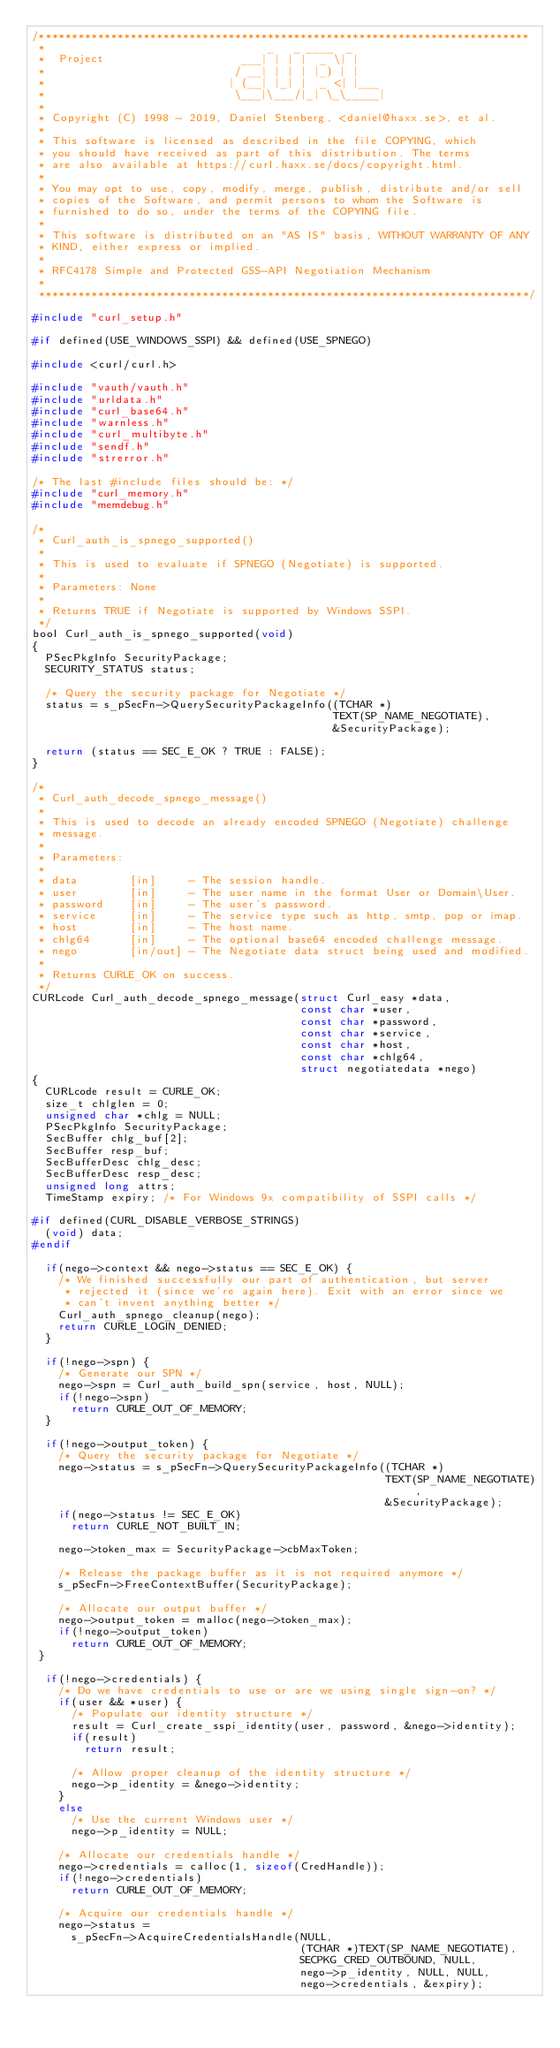<code> <loc_0><loc_0><loc_500><loc_500><_C_>/***************************************************************************
 *                                  _   _ ____  _
 *  Project                     ___| | | |  _ \| |
 *                             / __| | | | |_) | |
 *                            | (__| |_| |  _ <| |___
 *                             \___|\___/|_| \_\_____|
 *
 * Copyright (C) 1998 - 2019, Daniel Stenberg, <daniel@haxx.se>, et al.
 *
 * This software is licensed as described in the file COPYING, which
 * you should have received as part of this distribution. The terms
 * are also available at https://curl.haxx.se/docs/copyright.html.
 *
 * You may opt to use, copy, modify, merge, publish, distribute and/or sell
 * copies of the Software, and permit persons to whom the Software is
 * furnished to do so, under the terms of the COPYING file.
 *
 * This software is distributed on an "AS IS" basis, WITHOUT WARRANTY OF ANY
 * KIND, either express or implied.
 *
 * RFC4178 Simple and Protected GSS-API Negotiation Mechanism
 *
 ***************************************************************************/

#include "curl_setup.h"

#if defined(USE_WINDOWS_SSPI) && defined(USE_SPNEGO)

#include <curl/curl.h>

#include "vauth/vauth.h"
#include "urldata.h"
#include "curl_base64.h"
#include "warnless.h"
#include "curl_multibyte.h"
#include "sendf.h"
#include "strerror.h"

/* The last #include files should be: */
#include "curl_memory.h"
#include "memdebug.h"

/*
 * Curl_auth_is_spnego_supported()
 *
 * This is used to evaluate if SPNEGO (Negotiate) is supported.
 *
 * Parameters: None
 *
 * Returns TRUE if Negotiate is supported by Windows SSPI.
 */
bool Curl_auth_is_spnego_supported(void)
{
  PSecPkgInfo SecurityPackage;
  SECURITY_STATUS status;

  /* Query the security package for Negotiate */
  status = s_pSecFn->QuerySecurityPackageInfo((TCHAR *)
                                              TEXT(SP_NAME_NEGOTIATE),
                                              &SecurityPackage);

  return (status == SEC_E_OK ? TRUE : FALSE);
}

/*
 * Curl_auth_decode_spnego_message()
 *
 * This is used to decode an already encoded SPNEGO (Negotiate) challenge
 * message.
 *
 * Parameters:
 *
 * data        [in]     - The session handle.
 * user        [in]     - The user name in the format User or Domain\User.
 * password    [in]     - The user's password.
 * service     [in]     - The service type such as http, smtp, pop or imap.
 * host        [in]     - The host name.
 * chlg64      [in]     - The optional base64 encoded challenge message.
 * nego        [in/out] - The Negotiate data struct being used and modified.
 *
 * Returns CURLE_OK on success.
 */
CURLcode Curl_auth_decode_spnego_message(struct Curl_easy *data,
                                         const char *user,
                                         const char *password,
                                         const char *service,
                                         const char *host,
                                         const char *chlg64,
                                         struct negotiatedata *nego)
{
  CURLcode result = CURLE_OK;
  size_t chlglen = 0;
  unsigned char *chlg = NULL;
  PSecPkgInfo SecurityPackage;
  SecBuffer chlg_buf[2];
  SecBuffer resp_buf;
  SecBufferDesc chlg_desc;
  SecBufferDesc resp_desc;
  unsigned long attrs;
  TimeStamp expiry; /* For Windows 9x compatibility of SSPI calls */

#if defined(CURL_DISABLE_VERBOSE_STRINGS)
  (void) data;
#endif

  if(nego->context && nego->status == SEC_E_OK) {
    /* We finished successfully our part of authentication, but server
     * rejected it (since we're again here). Exit with an error since we
     * can't invent anything better */
    Curl_auth_spnego_cleanup(nego);
    return CURLE_LOGIN_DENIED;
  }

  if(!nego->spn) {
    /* Generate our SPN */
    nego->spn = Curl_auth_build_spn(service, host, NULL);
    if(!nego->spn)
      return CURLE_OUT_OF_MEMORY;
  }

  if(!nego->output_token) {
    /* Query the security package for Negotiate */
    nego->status = s_pSecFn->QuerySecurityPackageInfo((TCHAR *)
                                                      TEXT(SP_NAME_NEGOTIATE),
                                                      &SecurityPackage);
    if(nego->status != SEC_E_OK)
      return CURLE_NOT_BUILT_IN;

    nego->token_max = SecurityPackage->cbMaxToken;

    /* Release the package buffer as it is not required anymore */
    s_pSecFn->FreeContextBuffer(SecurityPackage);

    /* Allocate our output buffer */
    nego->output_token = malloc(nego->token_max);
    if(!nego->output_token)
      return CURLE_OUT_OF_MEMORY;
 }

  if(!nego->credentials) {
    /* Do we have credentials to use or are we using single sign-on? */
    if(user && *user) {
      /* Populate our identity structure */
      result = Curl_create_sspi_identity(user, password, &nego->identity);
      if(result)
        return result;

      /* Allow proper cleanup of the identity structure */
      nego->p_identity = &nego->identity;
    }
    else
      /* Use the current Windows user */
      nego->p_identity = NULL;

    /* Allocate our credentials handle */
    nego->credentials = calloc(1, sizeof(CredHandle));
    if(!nego->credentials)
      return CURLE_OUT_OF_MEMORY;

    /* Acquire our credentials handle */
    nego->status =
      s_pSecFn->AcquireCredentialsHandle(NULL,
                                         (TCHAR *)TEXT(SP_NAME_NEGOTIATE),
                                         SECPKG_CRED_OUTBOUND, NULL,
                                         nego->p_identity, NULL, NULL,
                                         nego->credentials, &expiry);</code> 